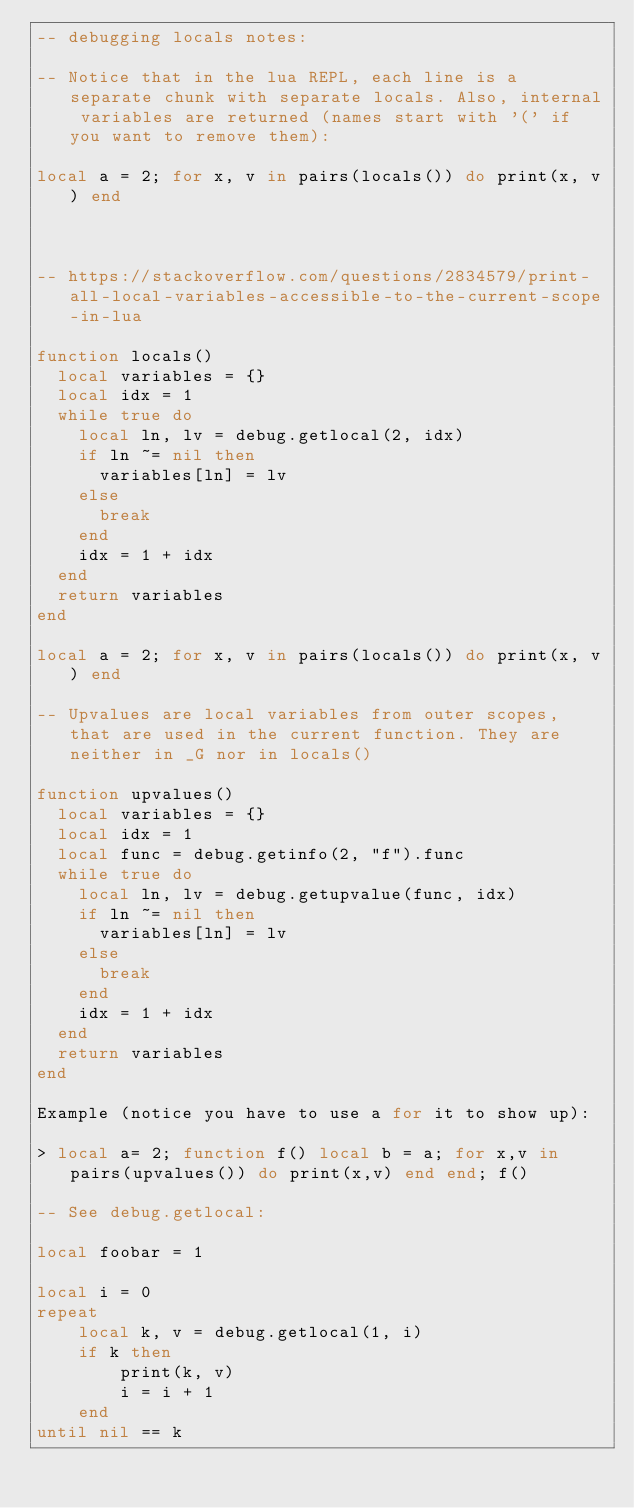<code> <loc_0><loc_0><loc_500><loc_500><_Lua_>-- debugging locals notes:

-- Notice that in the lua REPL, each line is a separate chunk with separate locals. Also, internal variables are returned (names start with '(' if you want to remove them):

local a = 2; for x, v in pairs(locals()) do print(x, v) end



-- https://stackoverflow.com/questions/2834579/print-all-local-variables-accessible-to-the-current-scope-in-lua

function locals()
  local variables = {}
  local idx = 1
  while true do
    local ln, lv = debug.getlocal(2, idx)
    if ln ~= nil then
      variables[ln] = lv
    else
      break
    end
    idx = 1 + idx
  end
  return variables
end

local a = 2; for x, v in pairs(locals()) do print(x, v) end

-- Upvalues are local variables from outer scopes, that are used in the current function. They are neither in _G nor in locals()

function upvalues()
  local variables = {}
  local idx = 1
  local func = debug.getinfo(2, "f").func
  while true do
    local ln, lv = debug.getupvalue(func, idx)
    if ln ~= nil then
      variables[ln] = lv
    else
      break
    end
    idx = 1 + idx
  end
  return variables
end

Example (notice you have to use a for it to show up):

> local a= 2; function f() local b = a; for x,v in pairs(upvalues()) do print(x,v) end end; f()

-- See debug.getlocal:

local foobar = 1

local i = 0
repeat
    local k, v = debug.getlocal(1, i)
    if k then
        print(k, v)
        i = i + 1
    end
until nil == k

</code> 